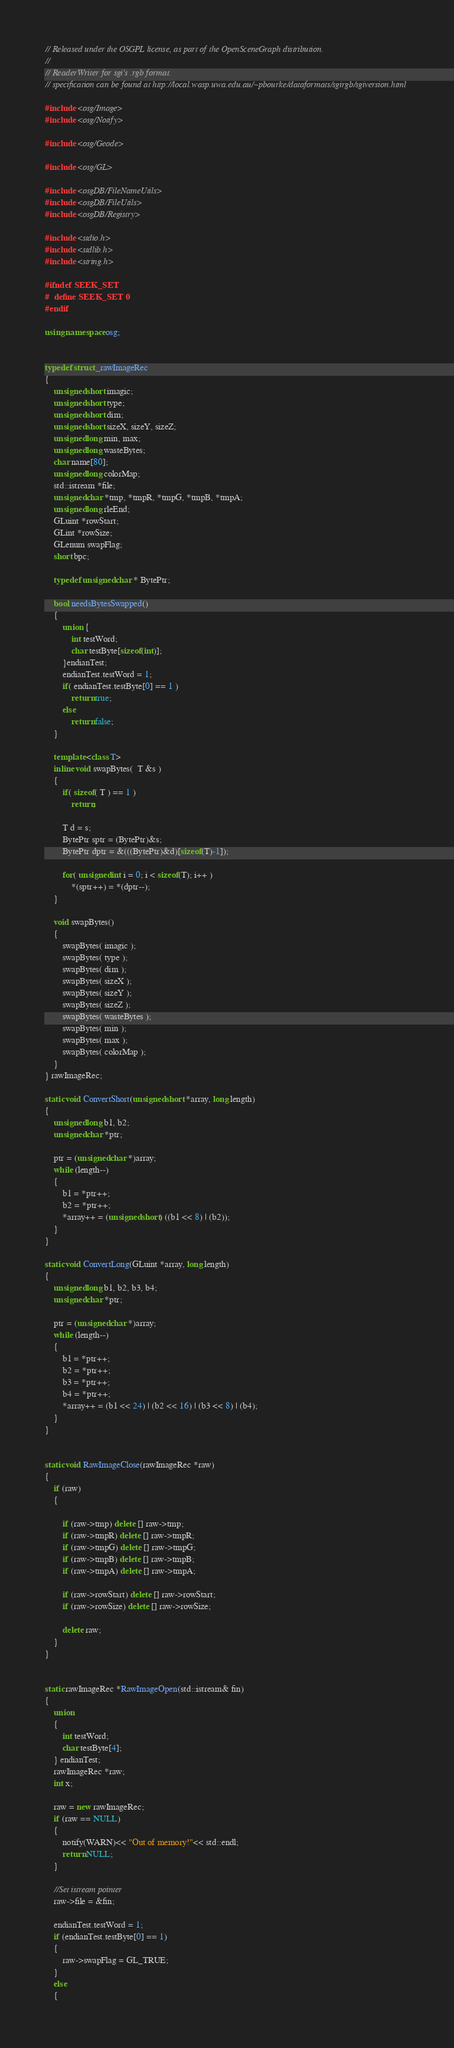<code> <loc_0><loc_0><loc_500><loc_500><_C++_>// Released under the OSGPL license, as part of the OpenSceneGraph distribution.
//
// ReaderWriter for sgi's .rgb format.
// specification can be found at http://local.wasp.uwa.edu.au/~pbourke/dataformats/sgirgb/sgiversion.html

#include <osg/Image>
#include <osg/Notify>

#include <osg/Geode>

#include <osg/GL>

#include <osgDB/FileNameUtils>
#include <osgDB/FileUtils>
#include <osgDB/Registry>

#include <stdio.h>
#include <stdlib.h>
#include <string.h>

#ifndef SEEK_SET
#  define SEEK_SET 0
#endif

using namespace osg;


typedef struct _rawImageRec
{
    unsigned short imagic;
    unsigned short type;
    unsigned short dim;
    unsigned short sizeX, sizeY, sizeZ;
    unsigned long min, max;
    unsigned long wasteBytes;
    char name[80];
    unsigned long colorMap;
    std::istream *file;
    unsigned char *tmp, *tmpR, *tmpG, *tmpB, *tmpA;
    unsigned long rleEnd;
    GLuint *rowStart;
    GLint *rowSize;
    GLenum swapFlag;
    short bpc;
  
    typedef unsigned char * BytePtr;

    bool needsBytesSwapped()
    {
        union {
            int testWord;
            char testByte[sizeof(int)];
        }endianTest; 
        endianTest.testWord = 1;
        if( endianTest.testByte[0] == 1 )
            return true;
        else
            return false;
    }

    template <class T>
    inline void swapBytes(  T &s )
    {
        if( sizeof( T ) == 1 ) 
            return;

        T d = s;
        BytePtr sptr = (BytePtr)&s;
        BytePtr dptr = &(((BytePtr)&d)[sizeof(T)-1]);

        for( unsigned int i = 0; i < sizeof(T); i++ )
            *(sptr++) = *(dptr--);
    }

    void swapBytes()
    {
        swapBytes( imagic );
        swapBytes( type );
        swapBytes( dim );
        swapBytes( sizeX );
        swapBytes( sizeY );
        swapBytes( sizeZ );
        swapBytes( wasteBytes );
        swapBytes( min );
        swapBytes( max );
        swapBytes( colorMap );
    }
} rawImageRec;

static void ConvertShort(unsigned short *array, long length)
{
    unsigned long b1, b2;
    unsigned char *ptr;

    ptr = (unsigned char *)array;
    while (length--)
    {
        b1 = *ptr++;
        b2 = *ptr++;
        *array++ = (unsigned short) ((b1 << 8) | (b2));
    }
}

static void ConvertLong(GLuint *array, long length)
{
    unsigned long b1, b2, b3, b4;
    unsigned char *ptr;

    ptr = (unsigned char *)array;
    while (length--)
    {
        b1 = *ptr++;
        b2 = *ptr++;
        b3 = *ptr++;
        b4 = *ptr++;
        *array++ = (b1 << 24) | (b2 << 16) | (b3 << 8) | (b4);
    }
}


static void RawImageClose(rawImageRec *raw)
{
    if (raw)
    {
        
        if (raw->tmp) delete [] raw->tmp;
        if (raw->tmpR) delete [] raw->tmpR;
        if (raw->tmpG) delete [] raw->tmpG;
        if (raw->tmpB) delete [] raw->tmpB;
        if (raw->tmpA) delete [] raw->tmpA;

        if (raw->rowStart) delete [] raw->rowStart;        
        if (raw->rowSize) delete [] raw->rowSize;        

        delete raw;
    }
}


static rawImageRec *RawImageOpen(std::istream& fin)
{
    union
    {
        int testWord;
        char testByte[4];
    } endianTest;
    rawImageRec *raw;
    int x;

    raw = new rawImageRec;
    if (raw == NULL)
    {
        notify(WARN)<< "Out of memory!"<< std::endl;
        return NULL;
    }

    //Set istream pointer
    raw->file = &fin;

    endianTest.testWord = 1;
    if (endianTest.testByte[0] == 1)
    {
        raw->swapFlag = GL_TRUE;
    }
    else
    {</code> 